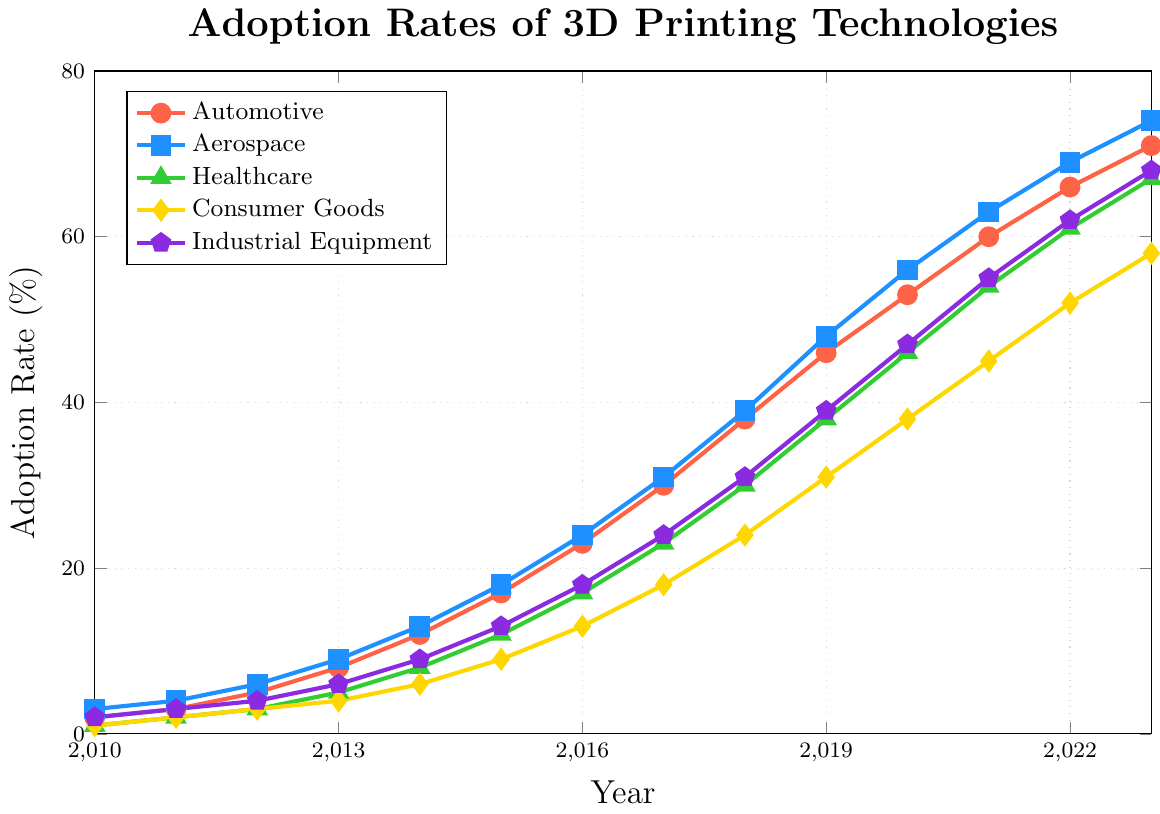What's the adoption rate of 3D printing in the automotive industry in 2015? Locate the automotive line (red) and the year 2015 on the x-axis, then read the adoption rate from the y-axis.
Answer: 17 Which industry had the highest adoption rate in 2013? Compare the adoption rates of all industries for the year 2013 by following their lines to the y-axis.
Answer: Aerospace How much did the adoption rate for the healthcare sector increase from 2012 to 2020? Find the healthcare line (green) and read the rates for 2012 and 2020: (2020: 46% - 2012: 3%). Subtract the 2012 value from the 2020 value.
Answer: 43% Between which years did the industrial equipment sector see the largest increase in adoption rate? Compare the increases between consecutive years by examining the steepness of the industrial equipment line (purple). Identify the steepest segment.
Answer: 2015 to 2016 By how many percentage points did the consumer goods adoption rate change between 2018 and 2021? Locate the consumer goods line (yellow) and read the rates for 2018 and 2021: (2021: 45% - 2018: 24%). Subtract the 2018 value from the 2021 value.
Answer: 21 What is the average adoption rate for the aerospace industry over the entire period? Add up the adoption rates for the aerospace line (blue) from 2010 to 2023: (3 + 4 + 6 + 9 + 13 + 18 + 24 + 31 + 39 + 48 + 56 + 63 + 69 + 74) = 457. Divide by the number of years (14).
Answer: 32.64 Did the adoption rate for any industry remain the same in any consecutive years? Examine each industry's line for flat segments where the adoption rate does not change between consecutive years.
Answer: No What is the adoption rate difference between the automotive and aerospace industries in 2023? Locate the values for both industries in 2023: Automotive (71%), Aerospace (74%). Subtract the automotive value from the aerospace value.
Answer: 3 In which year did the healthcare industry surpass a 30% adoption rate? Follow the healthcare line (green) and find the first year where the adoption rate exceeds 30%.
Answer: 2018 Which industry had the lowest adoption rate in 2010? Identify the lowest point among the lines for the year 2010.
Answer: Healthcare 